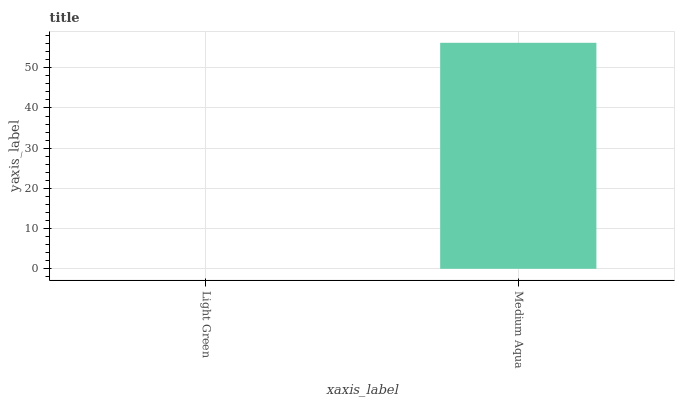Is Light Green the minimum?
Answer yes or no. Yes. Is Medium Aqua the maximum?
Answer yes or no. Yes. Is Medium Aqua the minimum?
Answer yes or no. No. Is Medium Aqua greater than Light Green?
Answer yes or no. Yes. Is Light Green less than Medium Aqua?
Answer yes or no. Yes. Is Light Green greater than Medium Aqua?
Answer yes or no. No. Is Medium Aqua less than Light Green?
Answer yes or no. No. Is Medium Aqua the high median?
Answer yes or no. Yes. Is Light Green the low median?
Answer yes or no. Yes. Is Light Green the high median?
Answer yes or no. No. Is Medium Aqua the low median?
Answer yes or no. No. 